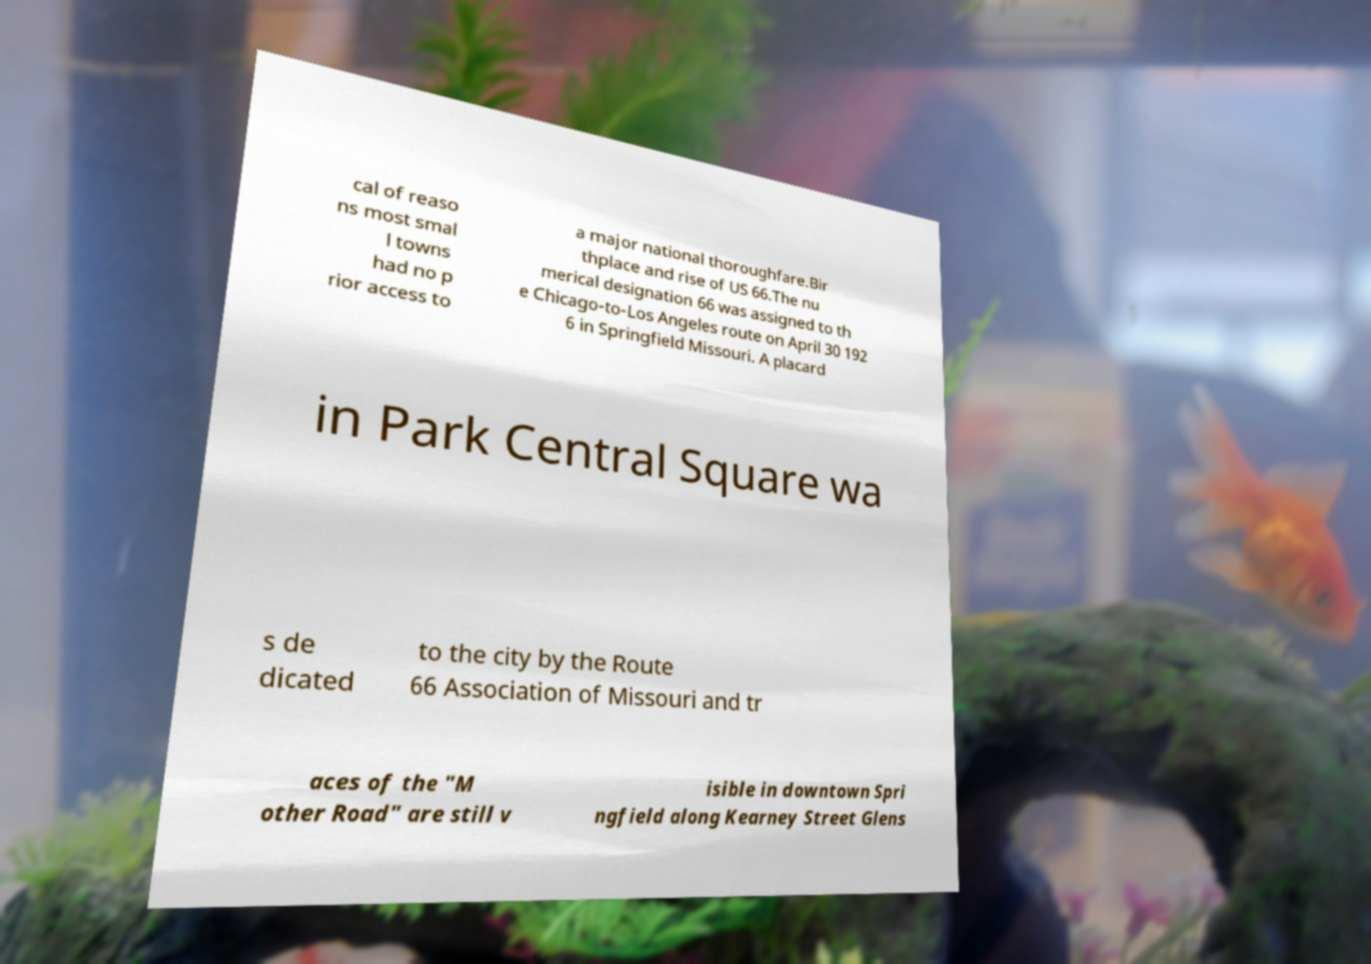Could you extract and type out the text from this image? cal of reaso ns most smal l towns had no p rior access to a major national thoroughfare.Bir thplace and rise of US 66.The nu merical designation 66 was assigned to th e Chicago-to-Los Angeles route on April 30 192 6 in Springfield Missouri. A placard in Park Central Square wa s de dicated to the city by the Route 66 Association of Missouri and tr aces of the "M other Road" are still v isible in downtown Spri ngfield along Kearney Street Glens 